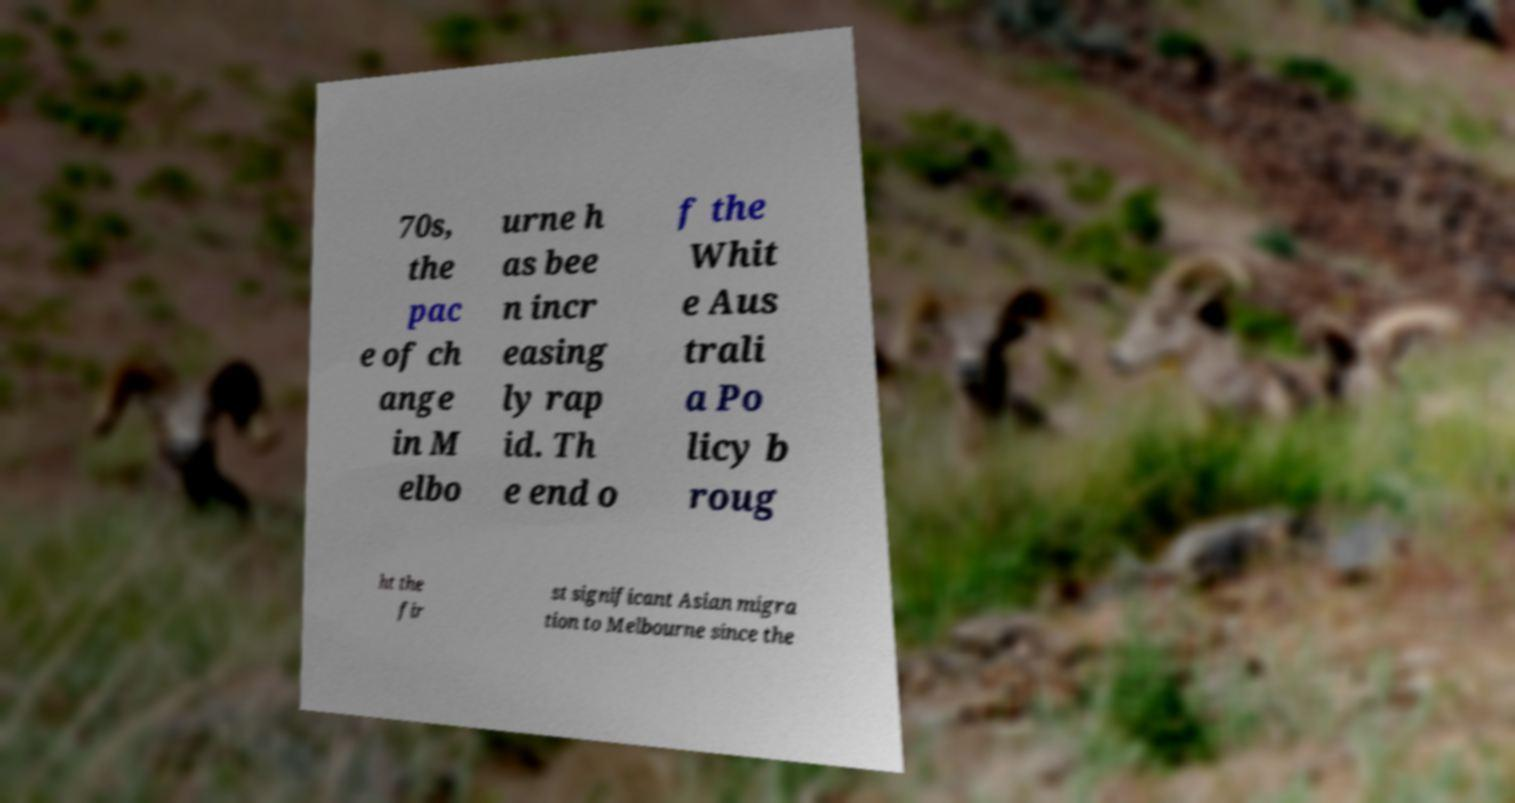What messages or text are displayed in this image? I need them in a readable, typed format. 70s, the pac e of ch ange in M elbo urne h as bee n incr easing ly rap id. Th e end o f the Whit e Aus trali a Po licy b roug ht the fir st significant Asian migra tion to Melbourne since the 